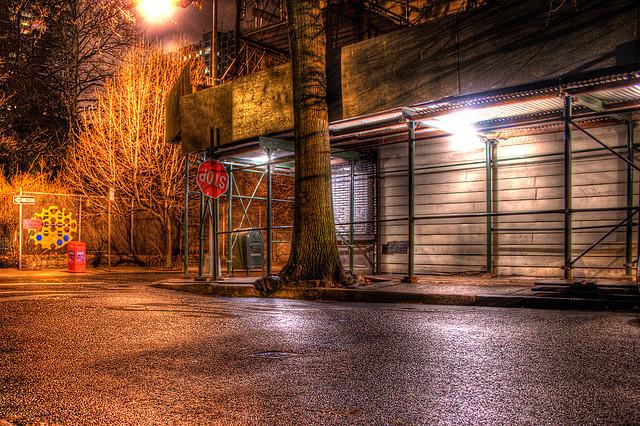Where is a one way sign?
Give a very brief answer. Left. Is the stop sign upside down?
Quick response, please. Yes. Are there lights on?
Be succinct. Yes. 